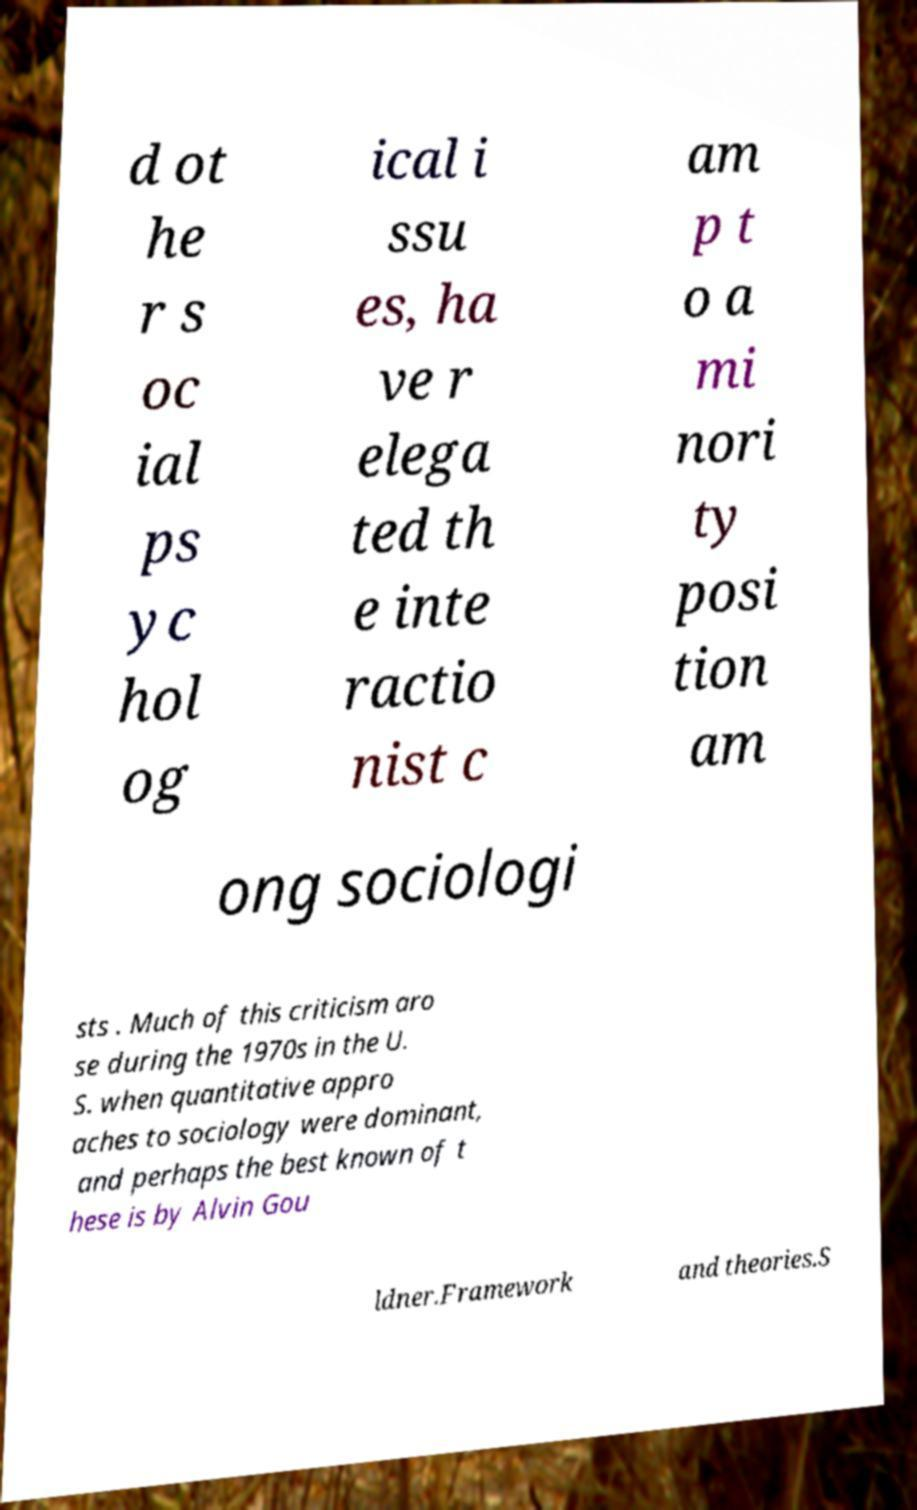Can you accurately transcribe the text from the provided image for me? d ot he r s oc ial ps yc hol og ical i ssu es, ha ve r elega ted th e inte ractio nist c am p t o a mi nori ty posi tion am ong sociologi sts . Much of this criticism aro se during the 1970s in the U. S. when quantitative appro aches to sociology were dominant, and perhaps the best known of t hese is by Alvin Gou ldner.Framework and theories.S 